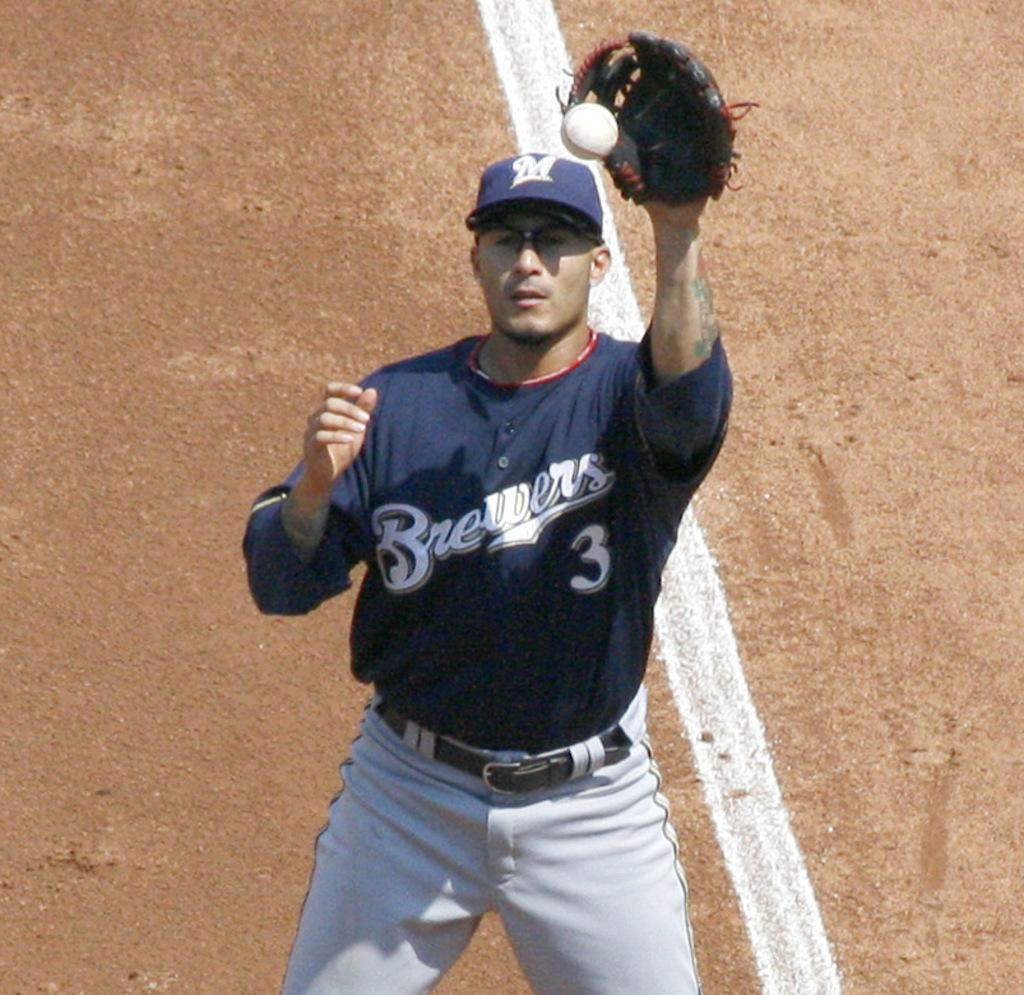<image>
Summarize the visual content of the image. a baseball player wearing a 'brewers 3 jersey 